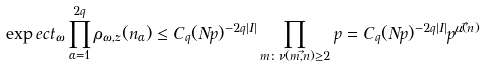<formula> <loc_0><loc_0><loc_500><loc_500>\exp e c t _ { \omega } \prod _ { \alpha = 1 } ^ { 2 q } \rho _ { \omega , z } ( n _ { \alpha } ) \leq C _ { q } ( N p ) ^ { - 2 q | I | } \prod _ { m \colon \nu ( m , \vec { n } ) \geq 2 } p = C _ { q } ( N p ) ^ { - 2 q | I | } p ^ { \mu ( \vec { n } ) }</formula> 